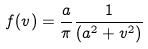<formula> <loc_0><loc_0><loc_500><loc_500>f ( v ) = \frac { a } { \pi } \frac { 1 } { ( a ^ { 2 } + v ^ { 2 } ) }</formula> 